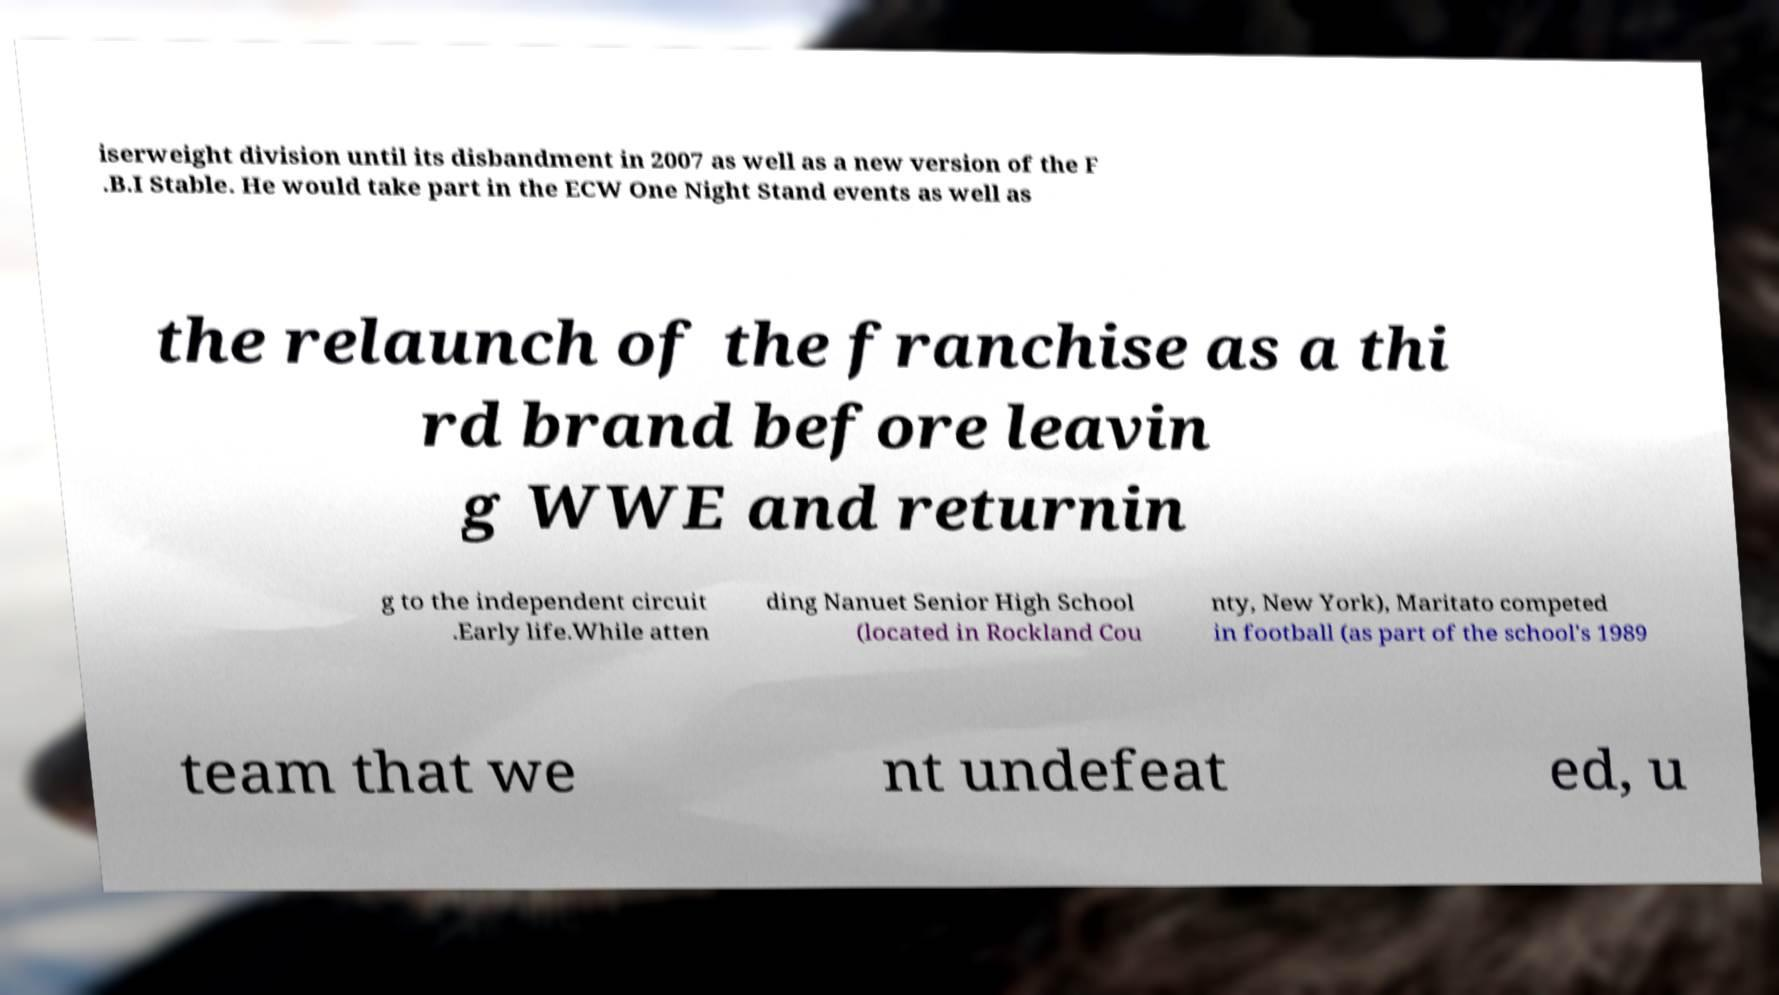Can you read and provide the text displayed in the image?This photo seems to have some interesting text. Can you extract and type it out for me? iserweight division until its disbandment in 2007 as well as a new version of the F .B.I Stable. He would take part in the ECW One Night Stand events as well as the relaunch of the franchise as a thi rd brand before leavin g WWE and returnin g to the independent circuit .Early life.While atten ding Nanuet Senior High School (located in Rockland Cou nty, New York), Maritato competed in football (as part of the school's 1989 team that we nt undefeat ed, u 